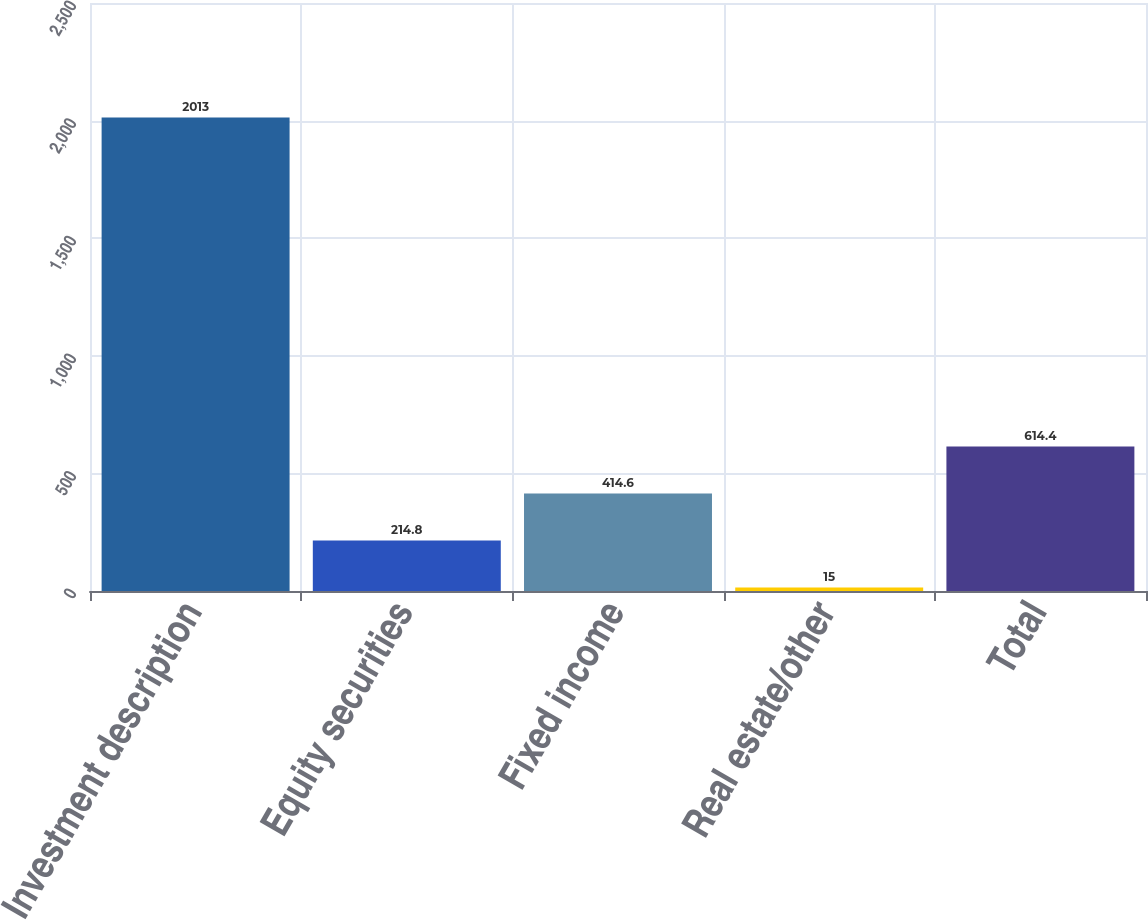Convert chart. <chart><loc_0><loc_0><loc_500><loc_500><bar_chart><fcel>Investment description<fcel>Equity securities<fcel>Fixed income<fcel>Real estate/other<fcel>Total<nl><fcel>2013<fcel>214.8<fcel>414.6<fcel>15<fcel>614.4<nl></chart> 